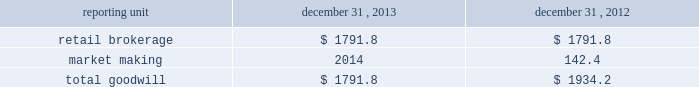Individual loan before being modified as a tdr in the discounted cash flow analysis in order to determine that specific loan 2019s expected impairment .
Specifically , a loan that has a more severe delinquency history prior to modification will have a higher future default rate in the discounted cash flow analysis than a loan that was not as severely delinquent .
For both of the one- to four-family and home equity loan portfolio segments , the pre- modification delinquency status , the borrower 2019s current credit score and other credit bureau attributes , in addition to each loan 2019s individual default experience and credit characteristics , are incorporated into the calculation of the specific allowance .
A specific allowance is established to the extent that the recorded investment exceeds the discounted cash flows of a tdr with a corresponding charge to provision for loan losses .
The specific allowance for these individually impaired loans represents the forecasted losses over the estimated remaining life of the loan , including the economic concession to the borrower .
Effects if actual results differ historic volatility in the credit markets has substantially increased the complexity and uncertainty involved in estimating the losses inherent in the loan portfolio .
In the current market it is difficult to estimate how potential changes in the quantitative and qualitative factors , including the impact of home equity lines of credit converting from interest only to amortizing loans or requiring borrowers to repay the loan in full at the end of the draw period , might impact the allowance for loan losses .
If our underlying assumptions and judgments prove to be inaccurate , the allowance for loan losses could be insufficient to cover actual losses .
We may be required under such circumstances to further increase the provision for loan losses , which could have an adverse effect on the regulatory capital position and results of operations in future periods .
During the normal course of conducting examinations , our banking regulators , the occ and federal reserve , continue to review our business and practices .
This process is dynamic and ongoing and we cannot be certain that additional changes or actions will not result from their continuing review .
Valuation of goodwill and other intangible assets description goodwill and other intangible assets are evaluated for impairment on an annual basis as of november 30 and in interim periods when events or changes indicate the carrying value may not be recoverable , such as a significant deterioration in the operating environment or a decision to sell or dispose of a reporting unit .
Goodwill and other intangible assets net of amortization were $ 1.8 billion and $ 0.2 billion , respectively , at december 31 , 2013 .
Judgments goodwill is allocated to reporting units , which are components of the business that are one level below operating segments .
Reporting units are evaluated for impairment individually during the annual assessment .
Estimating the fair value of reporting units and the assets , liabilities and intangible assets of a reporting unit is a subjective process that involves the use of estimates and judgments , particularly related to cash flows , the appropriate discount rates and an applicable control premium .
Management judgment is required to assess whether the carrying value of the reporting unit can be supported by the fair value of the individual reporting unit .
There are various valuation methodologies , such as the market approach or discounted cash flow methods , that may be used to estimate the fair value of reporting units .
In applying these methodologies , we utilize a number of factors , including actual operating results , future business plans , economic projections , and market data .
The table shows the comparative data for the amount of goodwill allocated to our reporting units ( dollars in millions ) : .

What percentage of total goodwill in 2012 is allocated to market making? 
Computations: (142.4 / 1934.2)
Answer: 0.07362. 